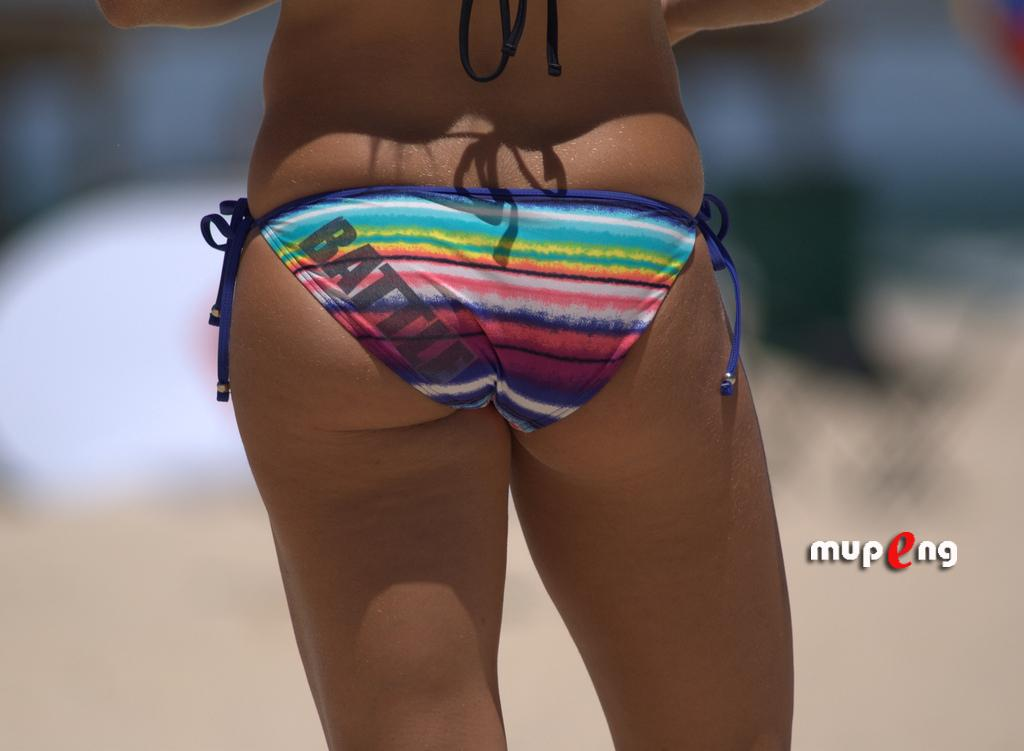What is the main subject of the image? There is a person standing in the image. Can you describe the background of the image? The background of the image is blurry. How many women with coiled legs are visible in the image? There are no women or coiled legs present in the image; it features a person standing against a blurry background. 